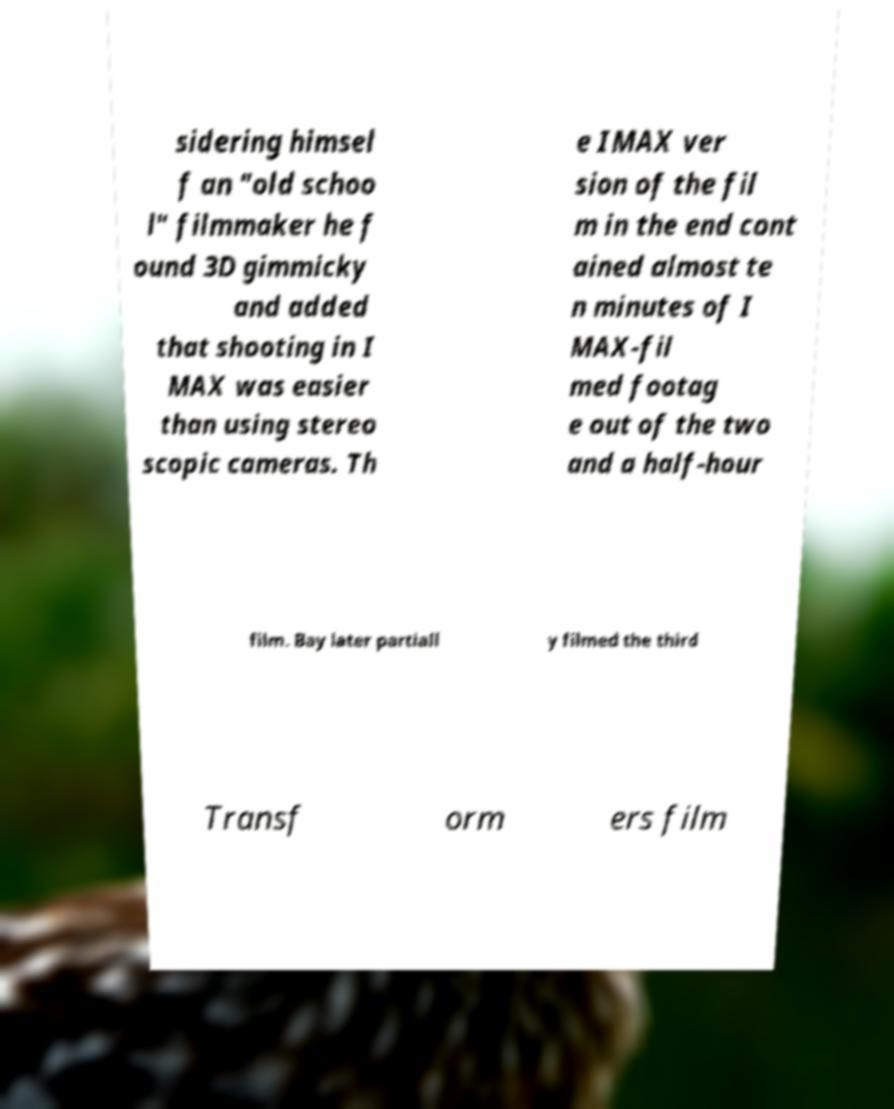There's text embedded in this image that I need extracted. Can you transcribe it verbatim? sidering himsel f an "old schoo l" filmmaker he f ound 3D gimmicky and added that shooting in I MAX was easier than using stereo scopic cameras. Th e IMAX ver sion of the fil m in the end cont ained almost te n minutes of I MAX-fil med footag e out of the two and a half-hour film. Bay later partiall y filmed the third Transf orm ers film 